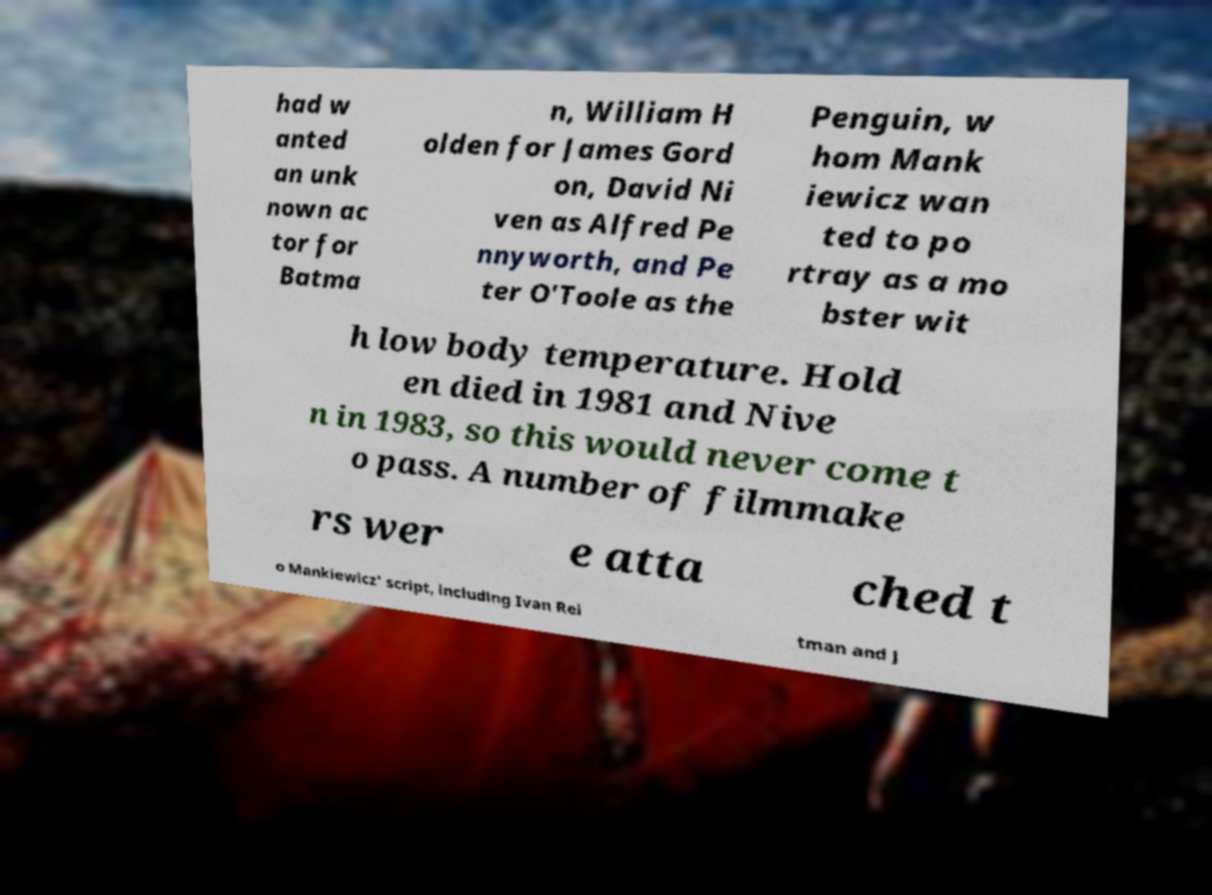Could you assist in decoding the text presented in this image and type it out clearly? had w anted an unk nown ac tor for Batma n, William H olden for James Gord on, David Ni ven as Alfred Pe nnyworth, and Pe ter O'Toole as the Penguin, w hom Mank iewicz wan ted to po rtray as a mo bster wit h low body temperature. Hold en died in 1981 and Nive n in 1983, so this would never come t o pass. A number of filmmake rs wer e atta ched t o Mankiewicz' script, including Ivan Rei tman and J 